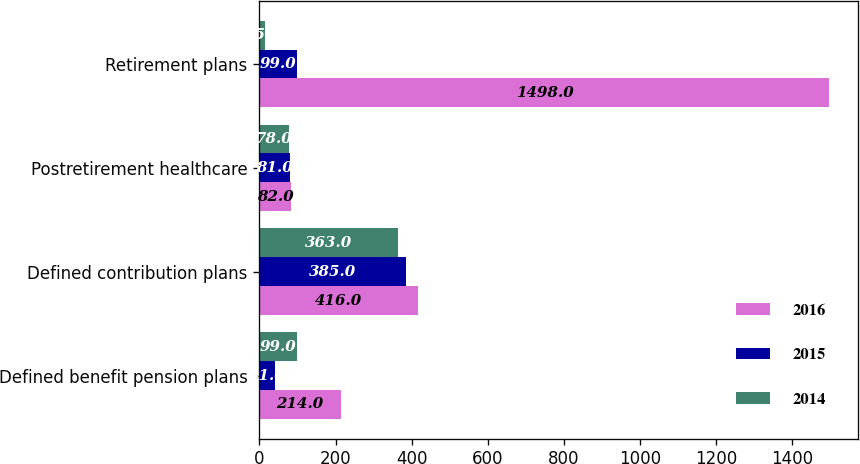Convert chart to OTSL. <chart><loc_0><loc_0><loc_500><loc_500><stacked_bar_chart><ecel><fcel>Defined benefit pension plans<fcel>Defined contribution plans<fcel>Postretirement healthcare<fcel>Retirement plans<nl><fcel>2016<fcel>214<fcel>416<fcel>82<fcel>1498<nl><fcel>2015<fcel>41<fcel>385<fcel>81<fcel>99<nl><fcel>2014<fcel>99<fcel>363<fcel>78<fcel>15<nl></chart> 